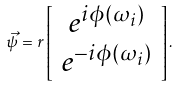Convert formula to latex. <formula><loc_0><loc_0><loc_500><loc_500>\vec { \psi } = r \left [ \begin{array} { c } e ^ { i \phi ( \omega _ { i } ) } \\ e ^ { - i \phi ( \omega _ { i } ) } \end{array} \right ] .</formula> 